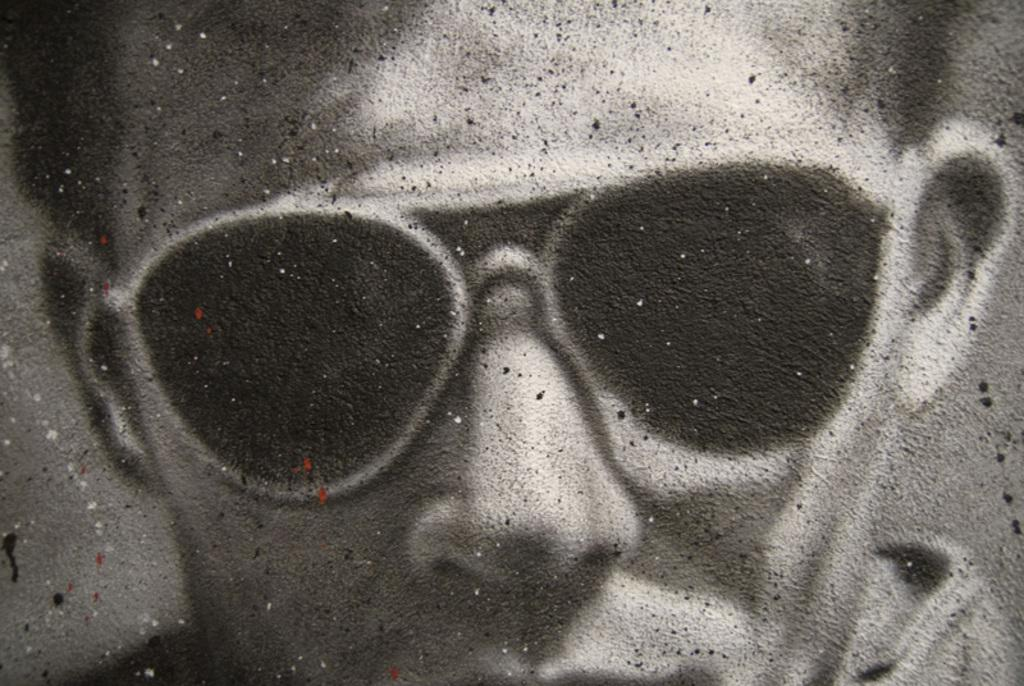What is the main subject of the image? The main subject of the image is a person's face. What is the person wearing in the image? The person is wearing goggles in the image. What type of order is the person giving in the image? There is no indication in the image that the person is giving any order. 